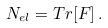Convert formula to latex. <formula><loc_0><loc_0><loc_500><loc_500>N _ { e l } = T r [ F ] \, .</formula> 